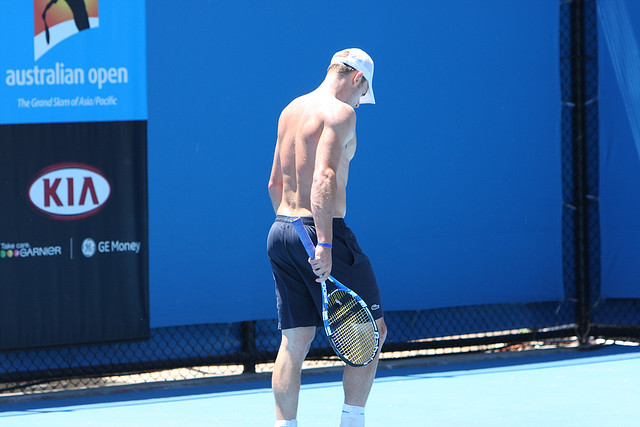Read and extract the text from this image. australian open KIA Money GE GARNER 